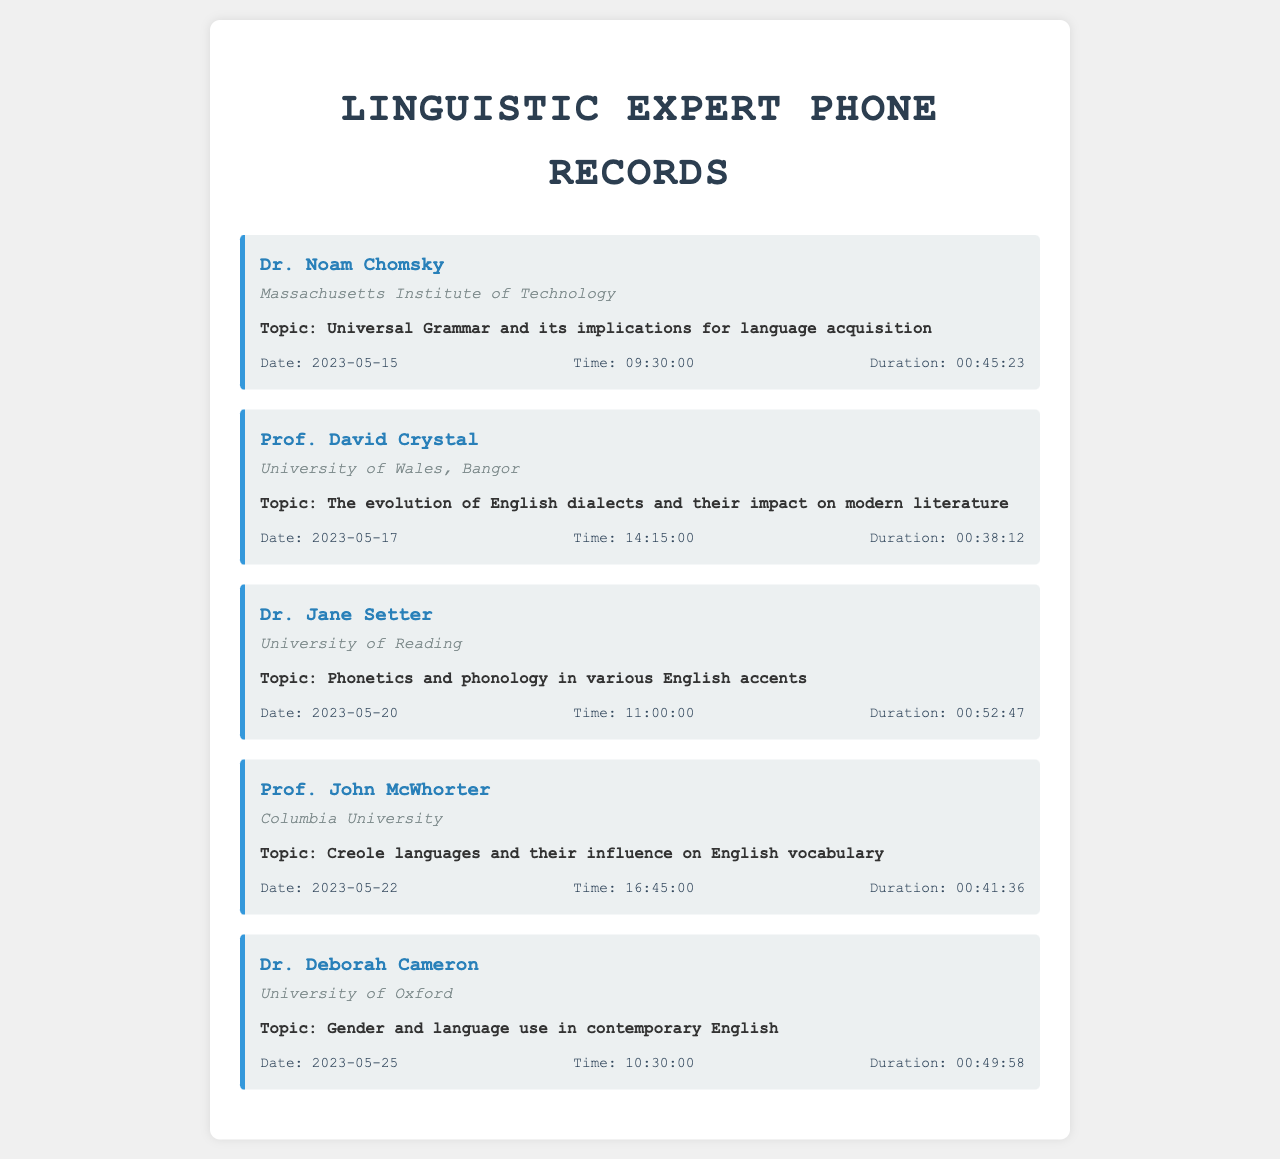What is the date of the conversation with Dr. Noam Chomsky? The date of the conversation with Dr. Noam Chomsky is specified in the document as 2023-05-15.
Answer: 2023-05-15 What institution is associated with Prof. David Crystal? The document states that Prof. David Crystal is associated with the University of Wales, Bangor.
Answer: University of Wales, Bangor How long was the conversation with Dr. Jane Setter? The duration of the conversation with Dr. Jane Setter is mentioned in the document as 00:52:47.
Answer: 00:52:47 Which topic did Prof. John McWhorter discuss? The topic discussed by Prof. John McWhorter is stated as "Creole languages and their influence on English vocabulary" in the document.
Answer: Creole languages and their influence on English vocabulary Who had the longest call duration? To determine this, we compare all the durations listed in the document. Dr. Jane Setter had the longest call at 00:52:47.
Answer: Dr. Jane Setter What time did the call with Dr. Deborah Cameron start? The document specifies the call with Dr. Deborah Cameron started at 10:30:00.
Answer: 10:30:00 What is the main focus of the conversation with Dr. Noam Chomsky? The main focus of the conversation with Dr. Noam Chomsky is about "Universal Grammar and its implications for language acquisition," as listed in the document.
Answer: Universal Grammar and its implications for language acquisition How many calls are documented in total? The document lists a total of five calls with linguistic experts.
Answer: Five 